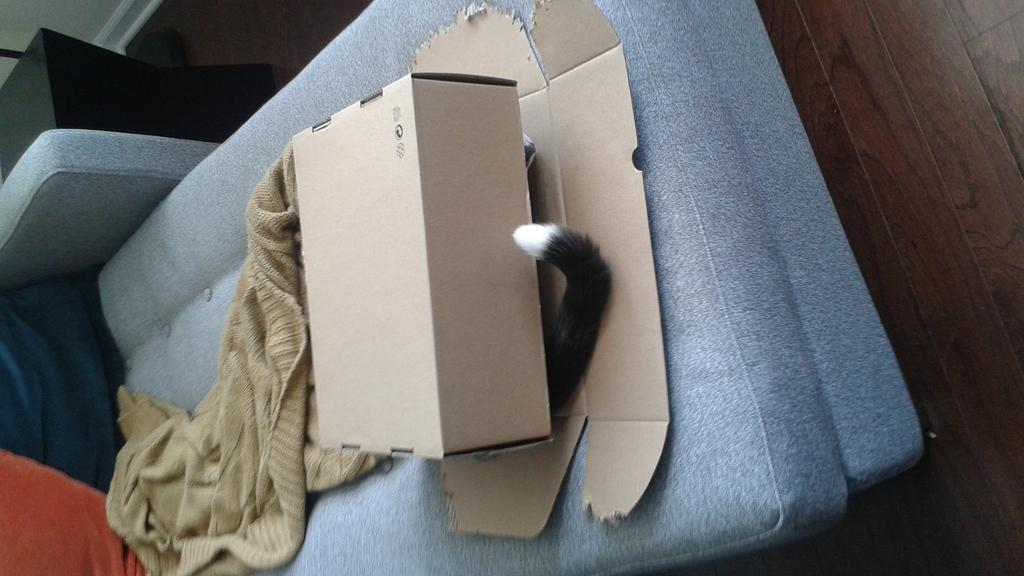Could you give a brief overview of what you see in this image? In this image I can see a cardboard box and I can see a tail in black and white color. I can see a towel and few objects on the blue color couch. 